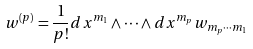<formula> <loc_0><loc_0><loc_500><loc_500>w ^ { ( p ) } = \frac { 1 } { p ! } d x ^ { m _ { 1 } } \wedge \cdots \wedge d x ^ { m _ { p } } w _ { m _ { p } \cdots m _ { 1 } }</formula> 